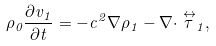<formula> <loc_0><loc_0><loc_500><loc_500>\rho _ { 0 } \frac { \partial v _ { 1 } } { \partial t } = - c ^ { 2 } \nabla \rho _ { 1 } - \nabla \cdot \stackrel { \leftrightarrow } { \tau } _ { 1 } ,</formula> 